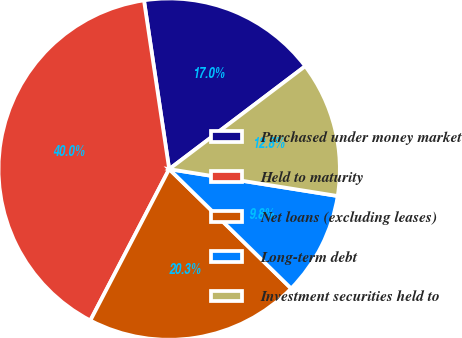<chart> <loc_0><loc_0><loc_500><loc_500><pie_chart><fcel>Purchased under money market<fcel>Held to maturity<fcel>Net loans (excluding leases)<fcel>Long-term debt<fcel>Investment securities held to<nl><fcel>17.05%<fcel>40.0%<fcel>20.32%<fcel>9.81%<fcel>12.83%<nl></chart> 